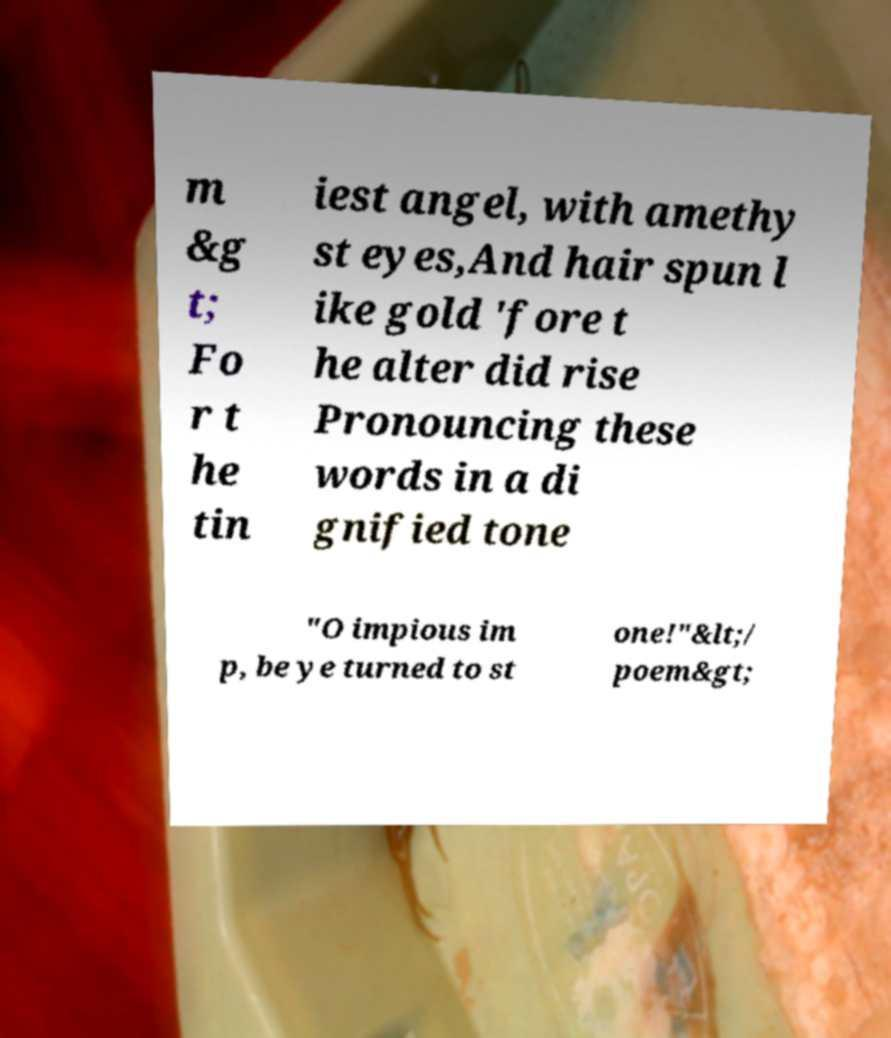There's text embedded in this image that I need extracted. Can you transcribe it verbatim? m &g t; Fo r t he tin iest angel, with amethy st eyes,And hair spun l ike gold 'fore t he alter did rise Pronouncing these words in a di gnified tone "O impious im p, be ye turned to st one!"&lt;/ poem&gt; 